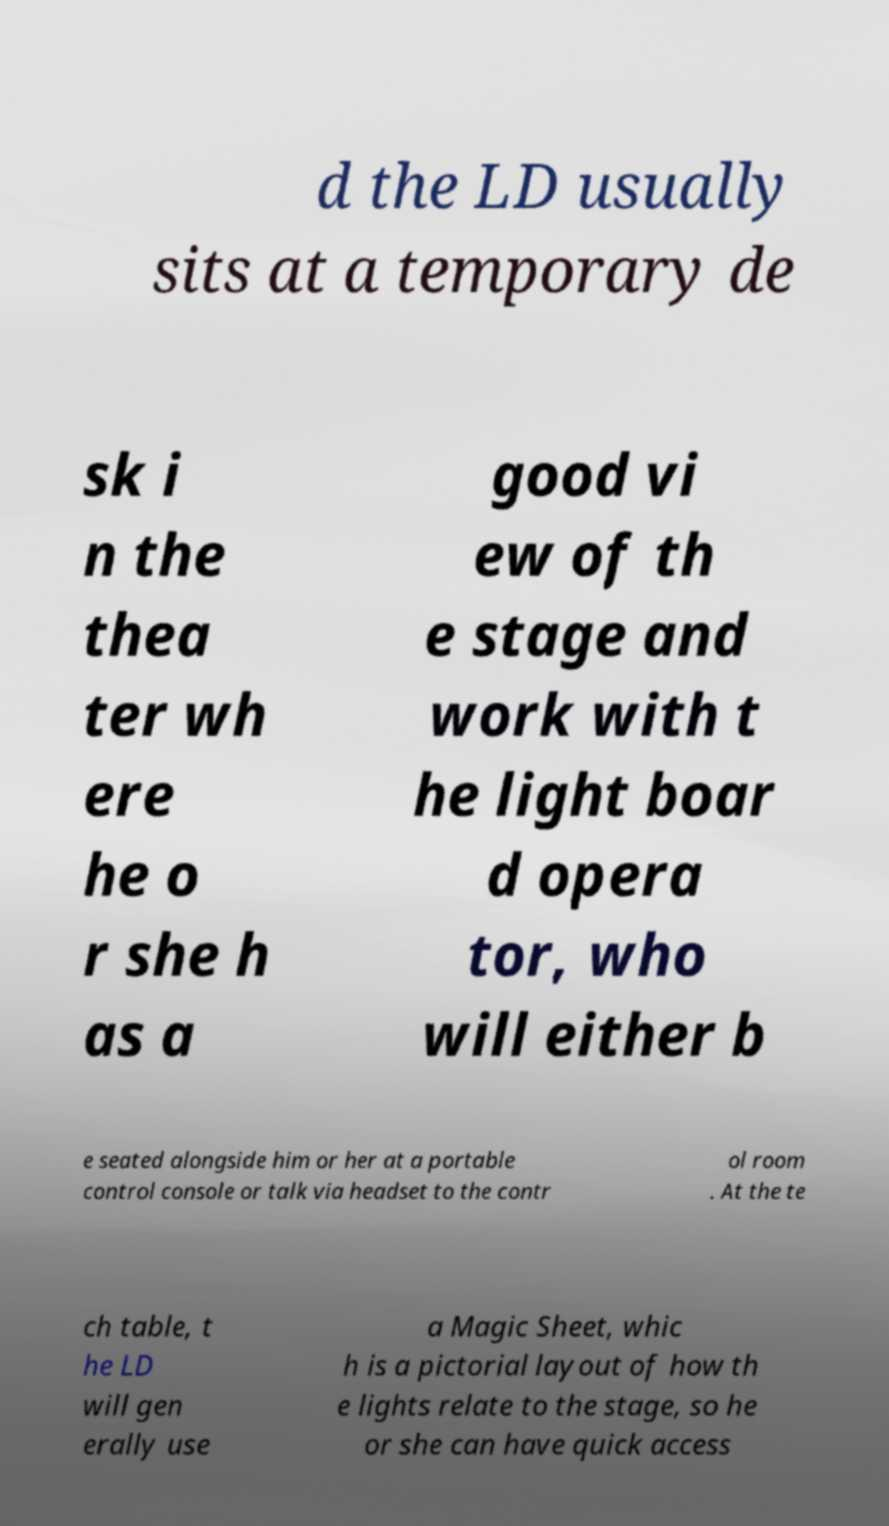Could you assist in decoding the text presented in this image and type it out clearly? d the LD usually sits at a temporary de sk i n the thea ter wh ere he o r she h as a good vi ew of th e stage and work with t he light boar d opera tor, who will either b e seated alongside him or her at a portable control console or talk via headset to the contr ol room . At the te ch table, t he LD will gen erally use a Magic Sheet, whic h is a pictorial layout of how th e lights relate to the stage, so he or she can have quick access 